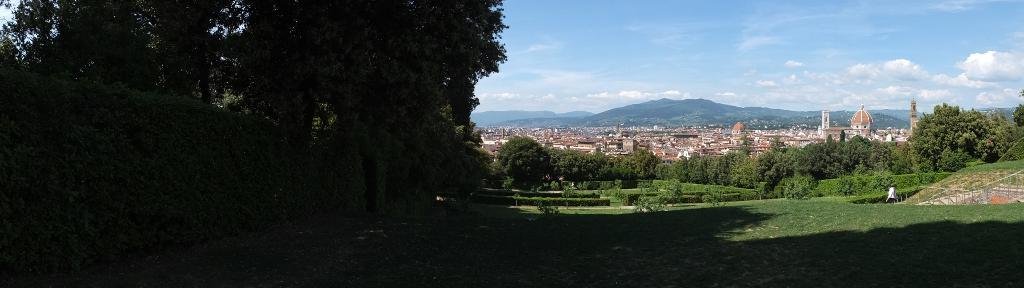What type of vegetation can be seen in the image? There are trees in the image. What is present at the bottom of the image? There is grass at the bottom of the image. What other landscaping features can be seen in the image? There are hedges in the image. What can be seen in the distance in the image? There are buildings, hills, and the sky visible in the background of the image. How many feet are visible in the image? There are no feet present in the image. What type of art can be seen hanging on the trees in the image? There is no art hanging on the trees in the image. 